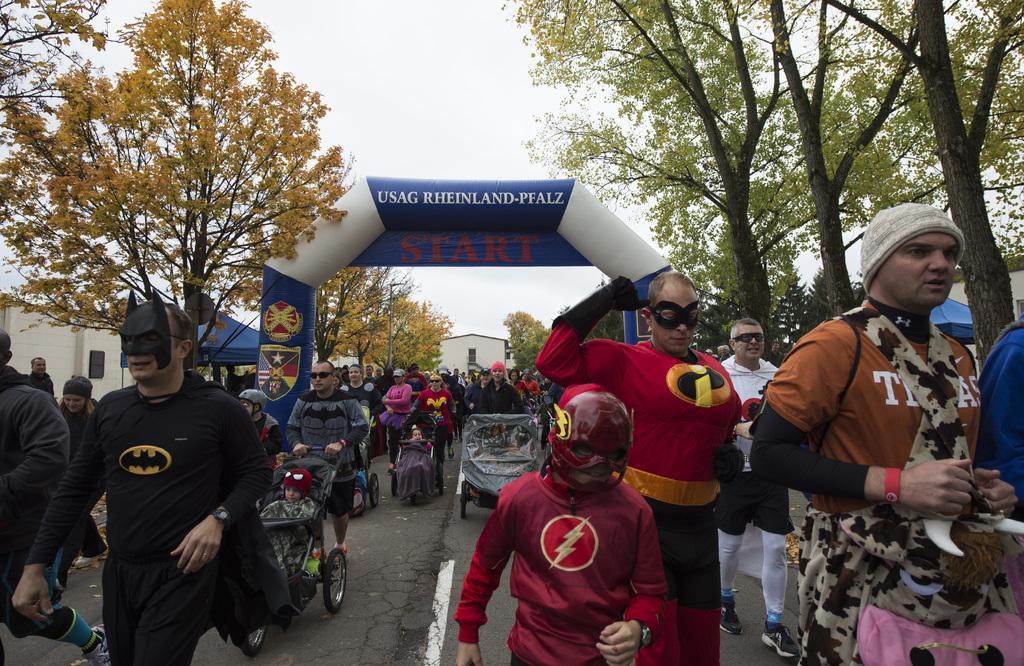Could you give a brief overview of what you see in this image? In this picture I can see group of people in fancy dresses, there are strollers, there is an inflatable arch, there are houses, canopy tents, there are trees, and in the background there is sky. 